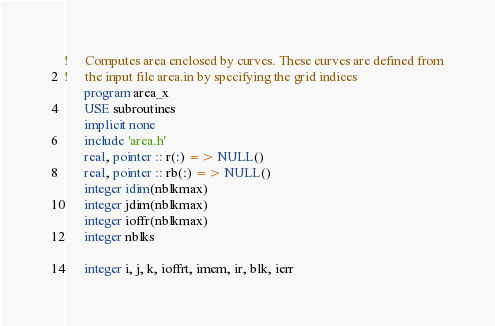Convert code to text. <code><loc_0><loc_0><loc_500><loc_500><_FORTRAN_>!     Computes area enclosed by curves. These curves are defined from
!     the input file area.in by specifying the grid indices
      program area_x
      USE subroutines
      implicit none
      include 'area.h'
      real, pointer :: r(:) => NULL()
      real, pointer :: rb(:) => NULL()
      integer idim(nblkmax)
      integer jdim(nblkmax)
      integer ioffr(nblkmax)
      integer nblks

      integer i, j, k, ioffrt, imem, ir, blk, ierr</code> 